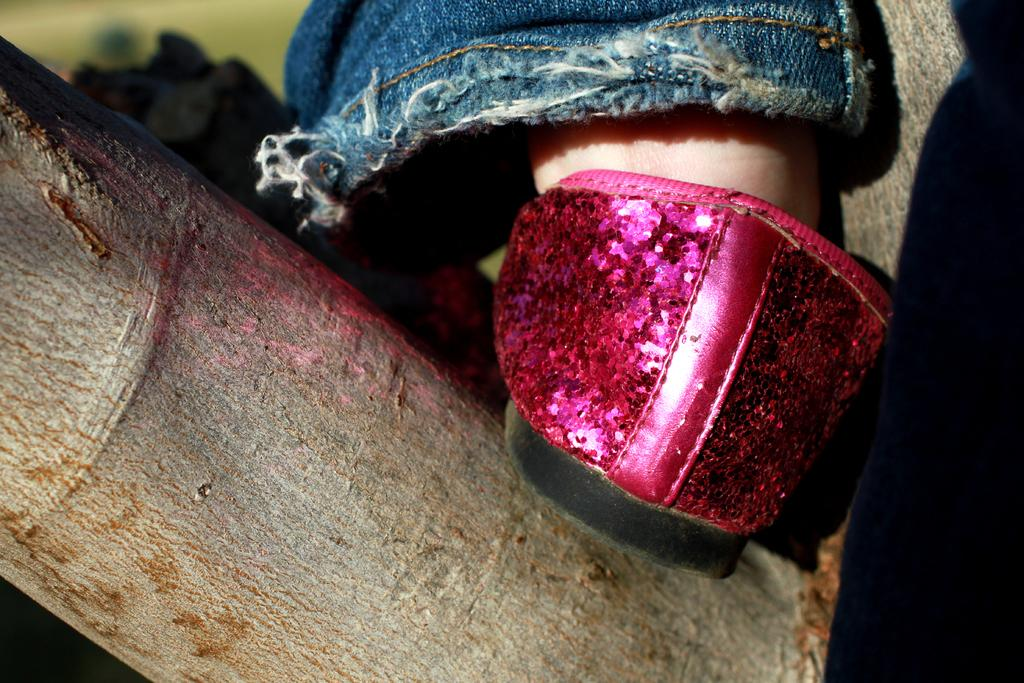What is the main subject of the image? The main subject of the image is a foot on a tree branch. What is the foot wearing in the image? There is a shoe in the image. What type of clothing is visible in the image? There is a pant in the image. How would you describe the background of the image? The background of the image is blurred. Can you see the border of the ocean in the image? There is no ocean or border present in the image; it features a foot on a tree branch. How many toes are visible on the foot in the image? The image does not show individual toes, only the foot as a whole. 